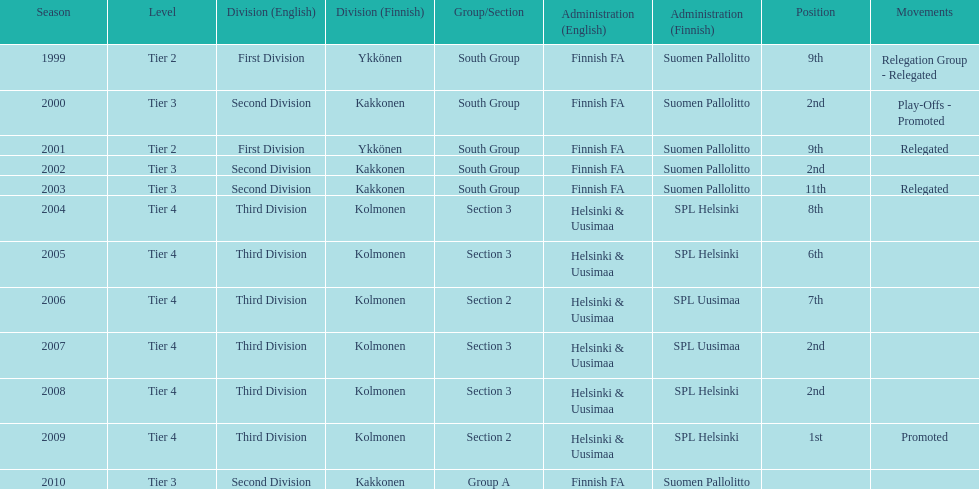What position did this team get after getting 9th place in 1999? 2nd. 